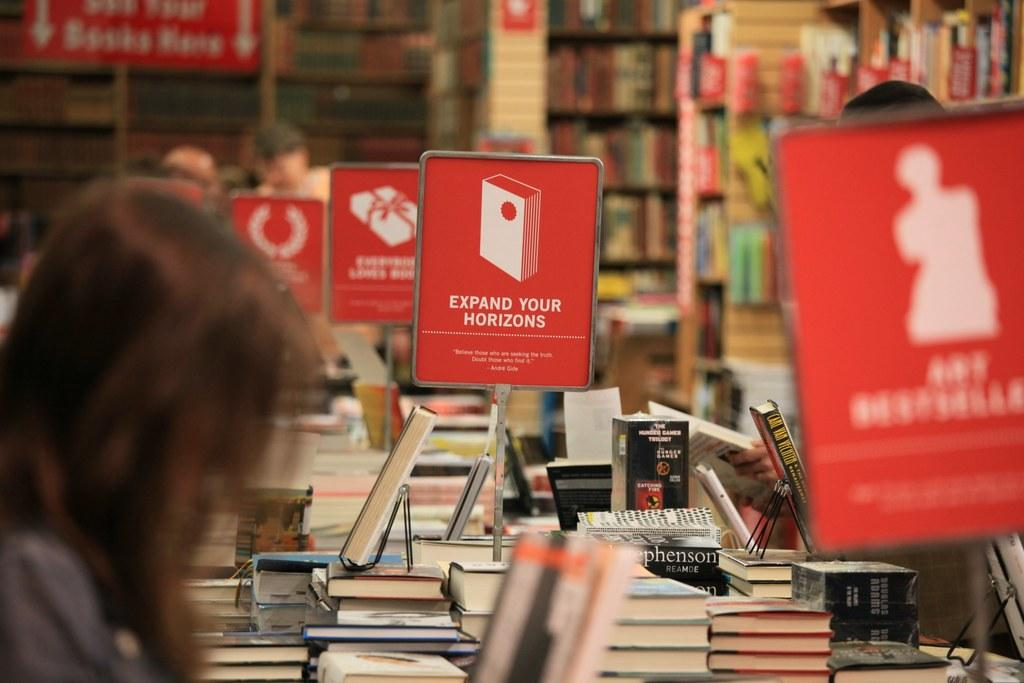Provide a one-sentence caption for the provided image. A lady looking at a book exhibit with different signs, one says expand your horizons. 